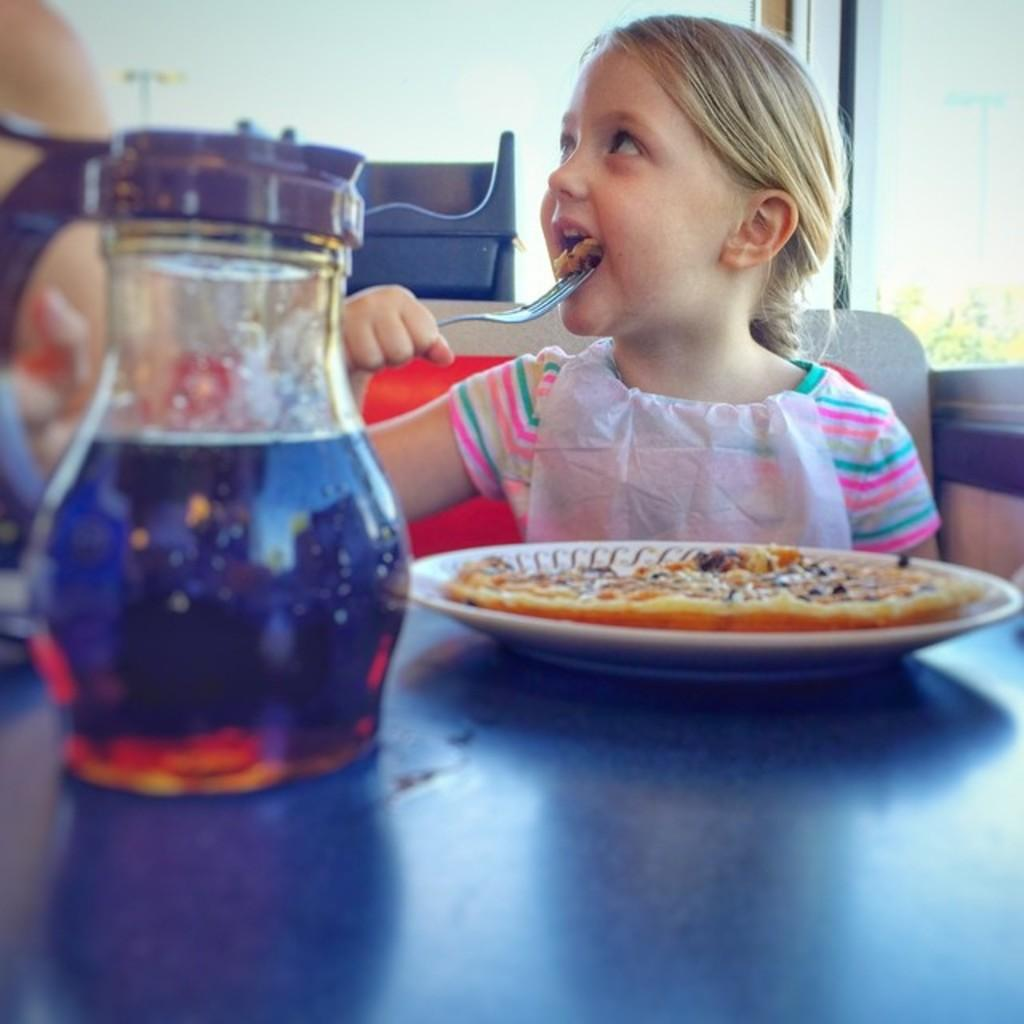What is the girl in the image doing? The girl is sitting in the image. What is the girl holding in the image? The girl is holding a fork. What can be seen on the table in the image? There is a jar and a white color plate in the image. What is on the plate in the image? There is food on the plate. What type of dinosaurs can be seen in the image? There are no dinosaurs present in the image. What time of day is it in the image? The provided facts do not mention the time of day, so it cannot be determined from the image. 